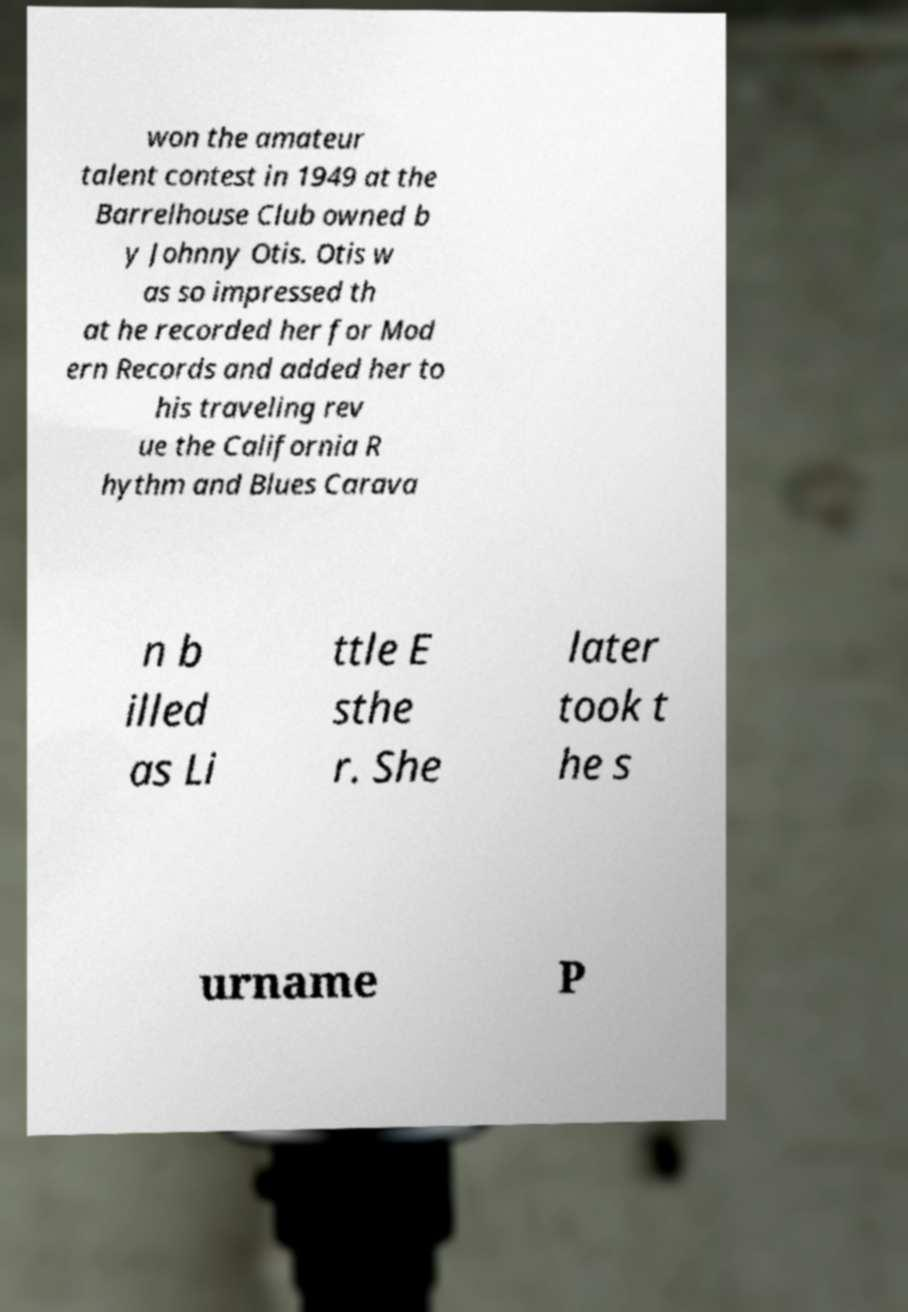What messages or text are displayed in this image? I need them in a readable, typed format. won the amateur talent contest in 1949 at the Barrelhouse Club owned b y Johnny Otis. Otis w as so impressed th at he recorded her for Mod ern Records and added her to his traveling rev ue the California R hythm and Blues Carava n b illed as Li ttle E sthe r. She later took t he s urname P 